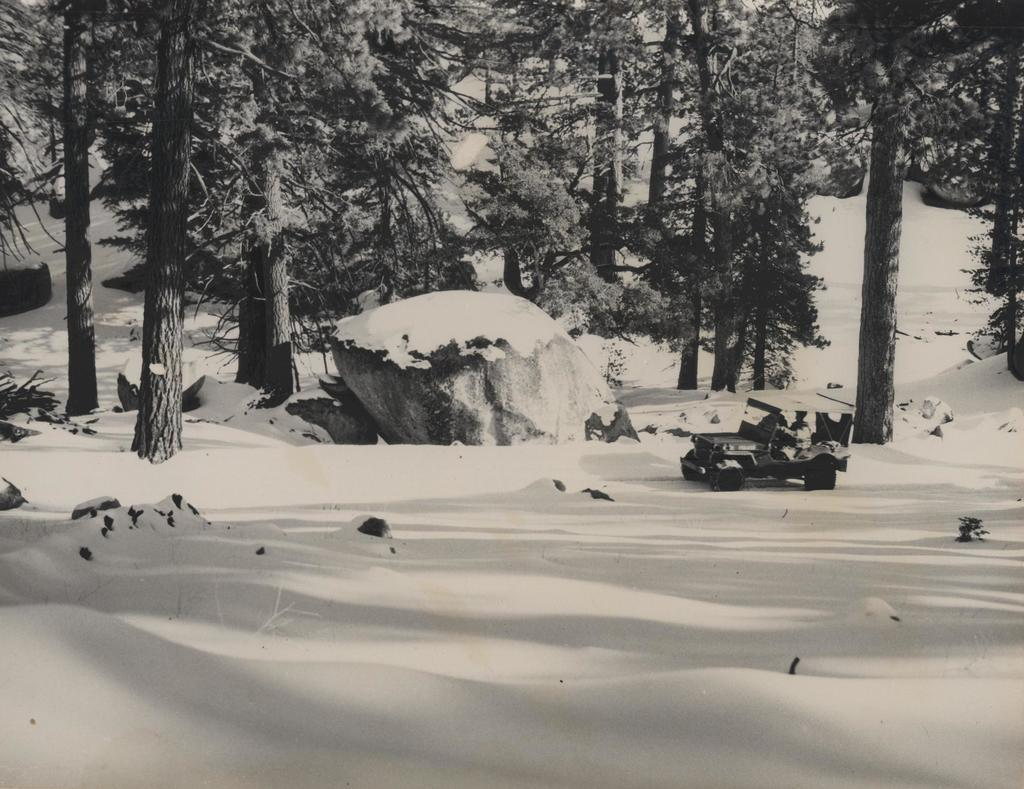What is the main subject of the image? There is a person in a jeep in the image. What is the condition of the ground in the image? The ground is covered with snow. What can be seen in the background of the image? There are trees and rocks covered with snow in the background of the image. Where is the structure of the lunchroom located in the image? There is no lunchroom present in the image; it features a person in a jeep on snow-covered ground with trees and rocks in the background. 